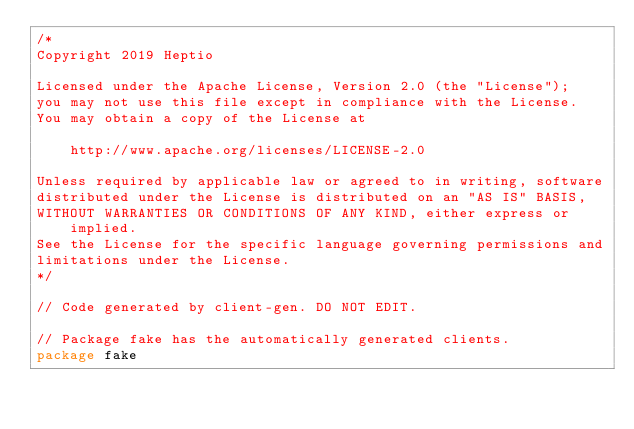<code> <loc_0><loc_0><loc_500><loc_500><_Go_>/*
Copyright 2019 Heptio

Licensed under the Apache License, Version 2.0 (the "License");
you may not use this file except in compliance with the License.
You may obtain a copy of the License at

    http://www.apache.org/licenses/LICENSE-2.0

Unless required by applicable law or agreed to in writing, software
distributed under the License is distributed on an "AS IS" BASIS,
WITHOUT WARRANTIES OR CONDITIONS OF ANY KIND, either express or implied.
See the License for the specific language governing permissions and
limitations under the License.
*/

// Code generated by client-gen. DO NOT EDIT.

// Package fake has the automatically generated clients.
package fake
</code> 